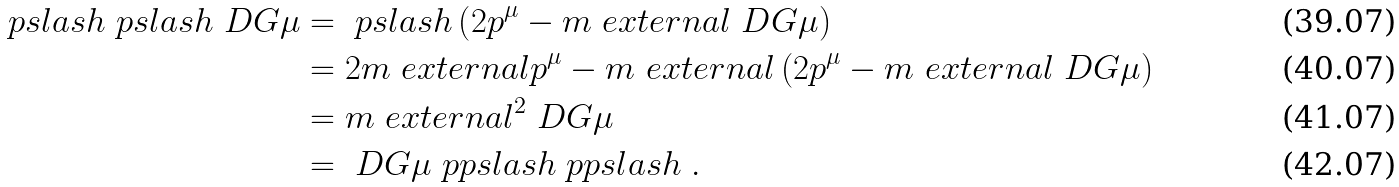<formula> <loc_0><loc_0><loc_500><loc_500>\ p s l a s h \ p s l a s h \ D G { \mu } & = \ p s l a s h \left ( 2 p ^ { \mu } - m _ { \ } e x t e r n a l \ D G { \mu } \right ) \\ & = 2 m _ { \ } e x t e r n a l p ^ { \mu } - m _ { \ } e x t e r n a l \left ( 2 p ^ { \mu } - m _ { \ } e x t e r n a l \ D G { \mu } \right ) \\ & = m _ { \ } e x t e r n a l ^ { 2 } \ D G { \mu } \\ & = \ D G { \mu } \ p p s l a s h \ p p s l a s h \ .</formula> 